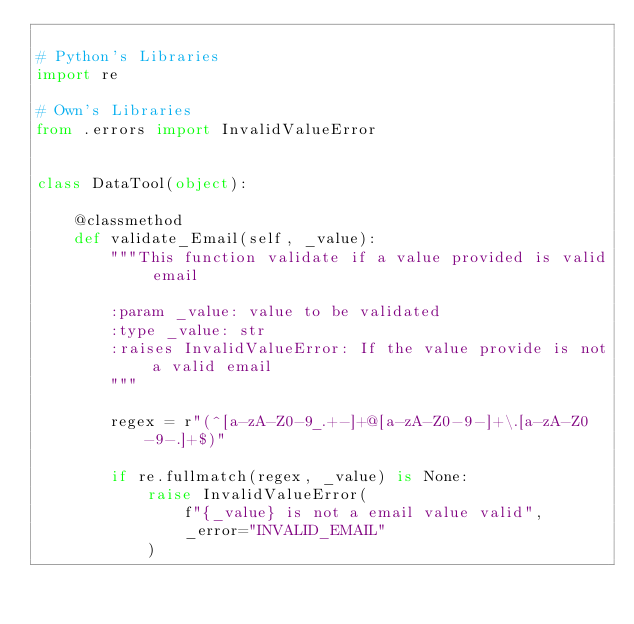<code> <loc_0><loc_0><loc_500><loc_500><_Python_>
# Python's Libraries
import re

# Own's Libraries
from .errors import InvalidValueError


class DataTool(object):

    @classmethod
    def validate_Email(self, _value):
        """This function validate if a value provided is valid email

        :param _value: value to be validated
        :type _value: str
        :raises InvalidValueError: If the value provide is not a valid email
        """

        regex = r"(^[a-zA-Z0-9_.+-]+@[a-zA-Z0-9-]+\.[a-zA-Z0-9-.]+$)"

        if re.fullmatch(regex, _value) is None:
            raise InvalidValueError(
                f"{_value} is not a email value valid",
                _error="INVALID_EMAIL"
            )
</code> 